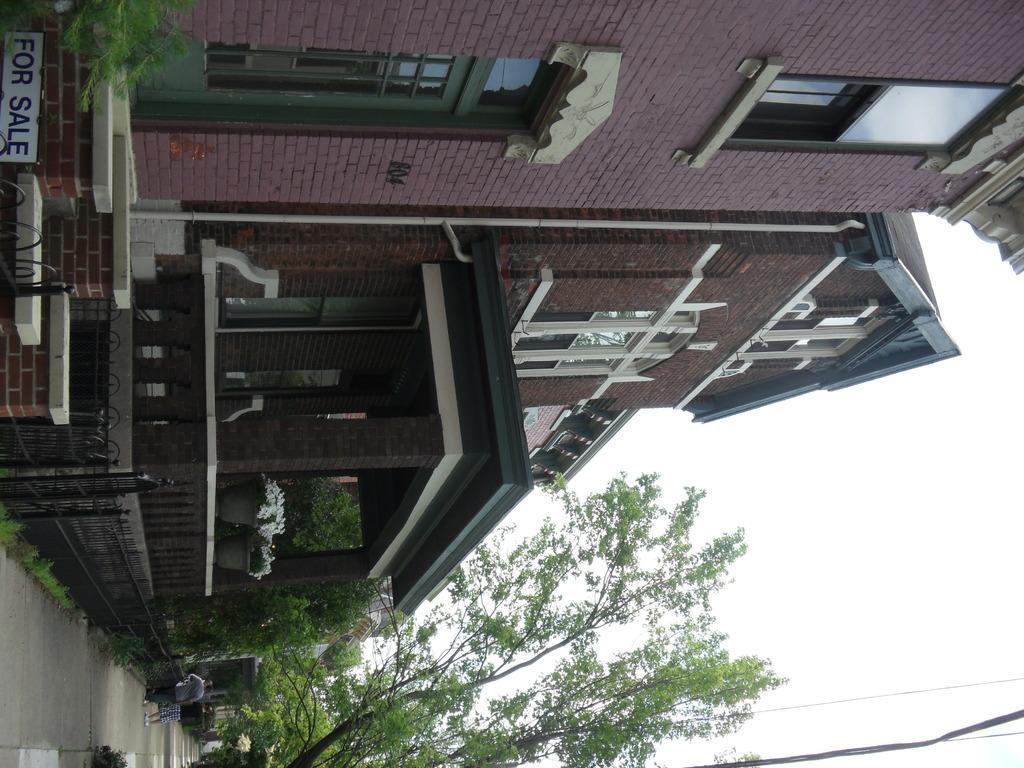In one or two sentences, can you explain what this image depicts? In the picture there is road, there are people standing, there are trees, there are houses, there is a clear sky. 